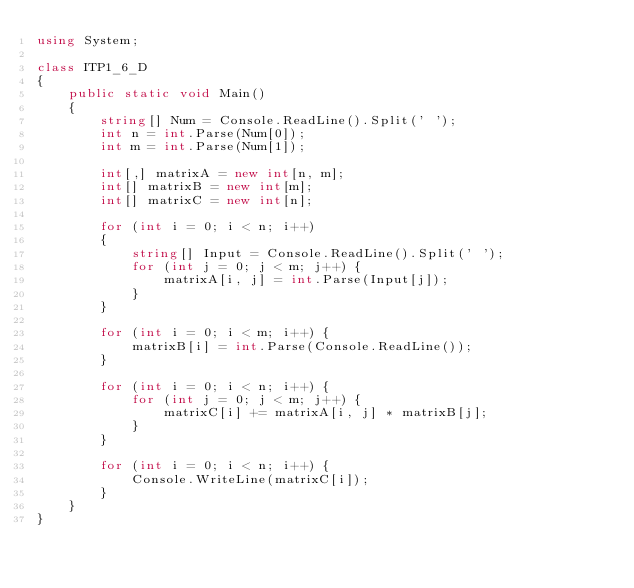Convert code to text. <code><loc_0><loc_0><loc_500><loc_500><_C#_>using System;

class ITP1_6_D
{
    public static void Main()
    {
        string[] Num = Console.ReadLine().Split(' ');
        int n = int.Parse(Num[0]);
        int m = int.Parse(Num[1]);

        int[,] matrixA = new int[n, m];
        int[] matrixB = new int[m];
        int[] matrixC = new int[n];

        for (int i = 0; i < n; i++)
        {
            string[] Input = Console.ReadLine().Split(' ');
            for (int j = 0; j < m; j++) {
                matrixA[i, j] = int.Parse(Input[j]);
            }
        }

        for (int i = 0; i < m; i++) {
            matrixB[i] = int.Parse(Console.ReadLine());
        }

        for (int i = 0; i < n; i++) {
            for (int j = 0; j < m; j++) {
                matrixC[i] += matrixA[i, j] * matrixB[j];
            }
        }

        for (int i = 0; i < n; i++) {
            Console.WriteLine(matrixC[i]);
        }
    }
}</code> 